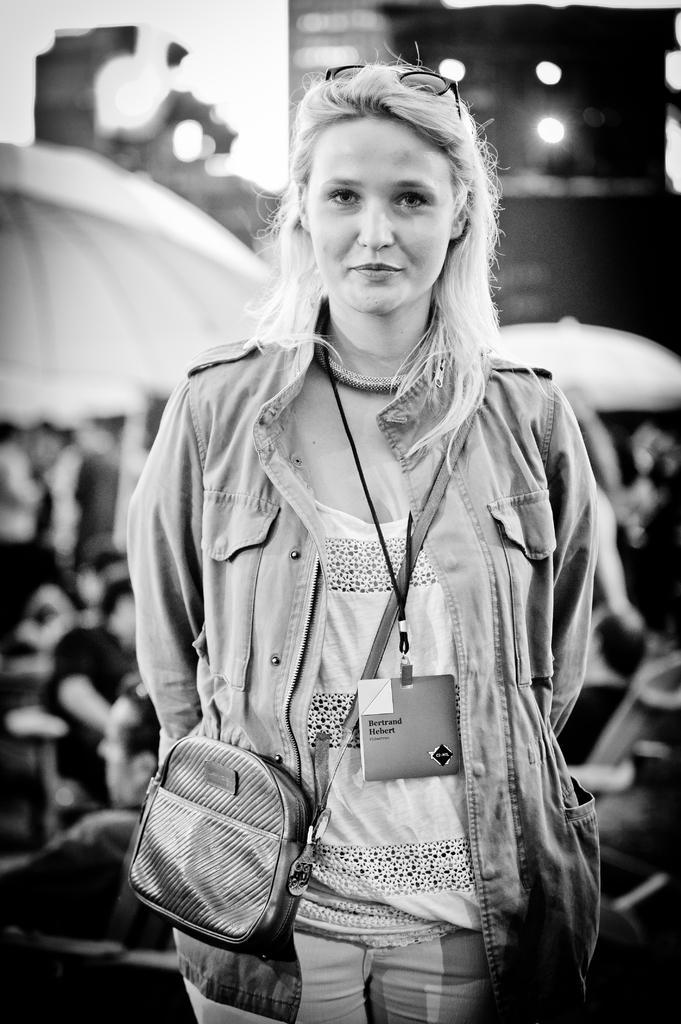Could you give a brief overview of what you see in this image? This is a black and white image. Here I can see a woman wearing a jacket, bag, standing, smiling and giving pose for the picture. At the back of this woman there are few people sitting under the umbrellas. The background is blurred. 